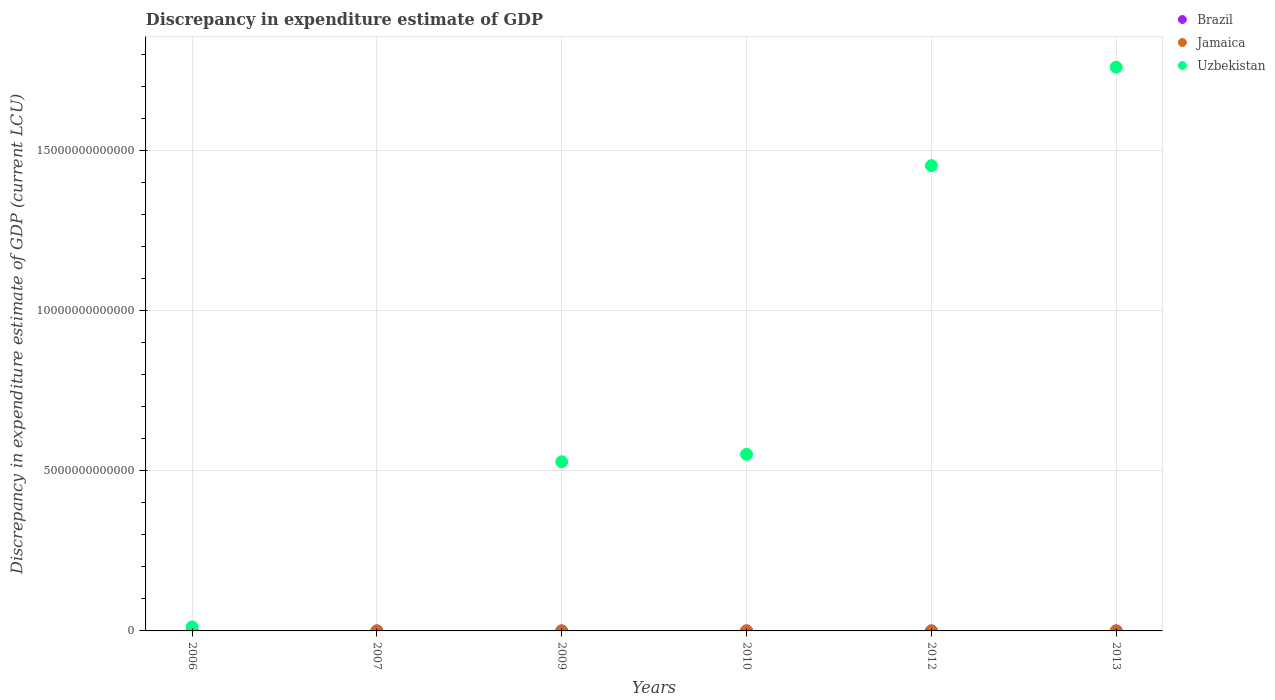Is the number of dotlines equal to the number of legend labels?
Provide a short and direct response. No. Across all years, what is the maximum discrepancy in expenditure estimate of GDP in Brazil?
Make the answer very short. 2.00e+06. In which year was the discrepancy in expenditure estimate of GDP in Uzbekistan maximum?
Make the answer very short. 2013. What is the total discrepancy in expenditure estimate of GDP in Jamaica in the graph?
Ensure brevity in your answer.  1.20e+06. What is the difference between the discrepancy in expenditure estimate of GDP in Jamaica in 2007 and that in 2012?
Provide a succinct answer. -8.00e+05. What is the difference between the discrepancy in expenditure estimate of GDP in Jamaica in 2006 and the discrepancy in expenditure estimate of GDP in Uzbekistan in 2010?
Provide a succinct answer. -5.51e+12. What is the average discrepancy in expenditure estimate of GDP in Brazil per year?
Provide a succinct answer. 6.67e+05. In the year 2010, what is the difference between the discrepancy in expenditure estimate of GDP in Brazil and discrepancy in expenditure estimate of GDP in Uzbekistan?
Offer a very short reply. -5.51e+12. What is the ratio of the discrepancy in expenditure estimate of GDP in Brazil in 2009 to that in 2010?
Your answer should be compact. 1. What is the difference between the highest and the second highest discrepancy in expenditure estimate of GDP in Brazil?
Offer a terse response. 1.00e+06. What is the difference between the highest and the lowest discrepancy in expenditure estimate of GDP in Jamaica?
Keep it short and to the point. 1.00e+06. In how many years, is the discrepancy in expenditure estimate of GDP in Jamaica greater than the average discrepancy in expenditure estimate of GDP in Jamaica taken over all years?
Your answer should be very brief. 1. Does the discrepancy in expenditure estimate of GDP in Jamaica monotonically increase over the years?
Make the answer very short. No. Is the discrepancy in expenditure estimate of GDP in Brazil strictly greater than the discrepancy in expenditure estimate of GDP in Uzbekistan over the years?
Your answer should be compact. No. Is the discrepancy in expenditure estimate of GDP in Uzbekistan strictly less than the discrepancy in expenditure estimate of GDP in Brazil over the years?
Ensure brevity in your answer.  No. How many dotlines are there?
Offer a terse response. 3. What is the difference between two consecutive major ticks on the Y-axis?
Ensure brevity in your answer.  5.00e+12. Does the graph contain any zero values?
Your response must be concise. Yes. Does the graph contain grids?
Your response must be concise. Yes. What is the title of the graph?
Keep it short and to the point. Discrepancy in expenditure estimate of GDP. What is the label or title of the X-axis?
Your answer should be very brief. Years. What is the label or title of the Y-axis?
Your answer should be very brief. Discrepancy in expenditure estimate of GDP (current LCU). What is the Discrepancy in expenditure estimate of GDP (current LCU) in Brazil in 2006?
Keep it short and to the point. 0. What is the Discrepancy in expenditure estimate of GDP (current LCU) of Jamaica in 2006?
Ensure brevity in your answer.  0. What is the Discrepancy in expenditure estimate of GDP (current LCU) of Uzbekistan in 2006?
Make the answer very short. 1.25e+11. What is the Discrepancy in expenditure estimate of GDP (current LCU) of Brazil in 2007?
Your answer should be compact. 0. What is the Discrepancy in expenditure estimate of GDP (current LCU) in Jamaica in 2007?
Your answer should be compact. 2.00e+05. What is the Discrepancy in expenditure estimate of GDP (current LCU) of Uzbekistan in 2007?
Ensure brevity in your answer.  0. What is the Discrepancy in expenditure estimate of GDP (current LCU) of Brazil in 2009?
Give a very brief answer. 1.00e+06. What is the Discrepancy in expenditure estimate of GDP (current LCU) of Jamaica in 2009?
Offer a very short reply. 0. What is the Discrepancy in expenditure estimate of GDP (current LCU) of Uzbekistan in 2009?
Your answer should be compact. 5.28e+12. What is the Discrepancy in expenditure estimate of GDP (current LCU) of Brazil in 2010?
Offer a terse response. 1.00e+06. What is the Discrepancy in expenditure estimate of GDP (current LCU) in Jamaica in 2010?
Make the answer very short. 0. What is the Discrepancy in expenditure estimate of GDP (current LCU) of Uzbekistan in 2010?
Keep it short and to the point. 5.51e+12. What is the Discrepancy in expenditure estimate of GDP (current LCU) of Jamaica in 2012?
Ensure brevity in your answer.  1.00e+06. What is the Discrepancy in expenditure estimate of GDP (current LCU) of Uzbekistan in 2012?
Make the answer very short. 1.45e+13. What is the Discrepancy in expenditure estimate of GDP (current LCU) in Brazil in 2013?
Your answer should be compact. 2.00e+06. What is the Discrepancy in expenditure estimate of GDP (current LCU) in Uzbekistan in 2013?
Provide a short and direct response. 1.76e+13. Across all years, what is the maximum Discrepancy in expenditure estimate of GDP (current LCU) of Brazil?
Make the answer very short. 2.00e+06. Across all years, what is the maximum Discrepancy in expenditure estimate of GDP (current LCU) in Jamaica?
Give a very brief answer. 1.00e+06. Across all years, what is the maximum Discrepancy in expenditure estimate of GDP (current LCU) in Uzbekistan?
Keep it short and to the point. 1.76e+13. What is the total Discrepancy in expenditure estimate of GDP (current LCU) in Brazil in the graph?
Your answer should be very brief. 4.00e+06. What is the total Discrepancy in expenditure estimate of GDP (current LCU) of Jamaica in the graph?
Ensure brevity in your answer.  1.20e+06. What is the total Discrepancy in expenditure estimate of GDP (current LCU) of Uzbekistan in the graph?
Your answer should be compact. 4.30e+13. What is the difference between the Discrepancy in expenditure estimate of GDP (current LCU) in Uzbekistan in 2006 and that in 2009?
Give a very brief answer. -5.15e+12. What is the difference between the Discrepancy in expenditure estimate of GDP (current LCU) of Uzbekistan in 2006 and that in 2010?
Give a very brief answer. -5.39e+12. What is the difference between the Discrepancy in expenditure estimate of GDP (current LCU) in Uzbekistan in 2006 and that in 2012?
Ensure brevity in your answer.  -1.44e+13. What is the difference between the Discrepancy in expenditure estimate of GDP (current LCU) of Uzbekistan in 2006 and that in 2013?
Ensure brevity in your answer.  -1.75e+13. What is the difference between the Discrepancy in expenditure estimate of GDP (current LCU) in Jamaica in 2007 and that in 2012?
Ensure brevity in your answer.  -8.00e+05. What is the difference between the Discrepancy in expenditure estimate of GDP (current LCU) in Brazil in 2009 and that in 2010?
Your answer should be compact. -0. What is the difference between the Discrepancy in expenditure estimate of GDP (current LCU) of Uzbekistan in 2009 and that in 2010?
Your response must be concise. -2.32e+11. What is the difference between the Discrepancy in expenditure estimate of GDP (current LCU) of Uzbekistan in 2009 and that in 2012?
Your response must be concise. -9.24e+12. What is the difference between the Discrepancy in expenditure estimate of GDP (current LCU) of Brazil in 2009 and that in 2013?
Offer a terse response. -1.00e+06. What is the difference between the Discrepancy in expenditure estimate of GDP (current LCU) in Uzbekistan in 2009 and that in 2013?
Your answer should be compact. -1.23e+13. What is the difference between the Discrepancy in expenditure estimate of GDP (current LCU) in Uzbekistan in 2010 and that in 2012?
Ensure brevity in your answer.  -9.01e+12. What is the difference between the Discrepancy in expenditure estimate of GDP (current LCU) of Uzbekistan in 2010 and that in 2013?
Ensure brevity in your answer.  -1.21e+13. What is the difference between the Discrepancy in expenditure estimate of GDP (current LCU) in Uzbekistan in 2012 and that in 2013?
Offer a terse response. -3.07e+12. What is the difference between the Discrepancy in expenditure estimate of GDP (current LCU) of Jamaica in 2007 and the Discrepancy in expenditure estimate of GDP (current LCU) of Uzbekistan in 2009?
Provide a short and direct response. -5.28e+12. What is the difference between the Discrepancy in expenditure estimate of GDP (current LCU) of Jamaica in 2007 and the Discrepancy in expenditure estimate of GDP (current LCU) of Uzbekistan in 2010?
Offer a terse response. -5.51e+12. What is the difference between the Discrepancy in expenditure estimate of GDP (current LCU) of Jamaica in 2007 and the Discrepancy in expenditure estimate of GDP (current LCU) of Uzbekistan in 2012?
Offer a terse response. -1.45e+13. What is the difference between the Discrepancy in expenditure estimate of GDP (current LCU) of Jamaica in 2007 and the Discrepancy in expenditure estimate of GDP (current LCU) of Uzbekistan in 2013?
Your response must be concise. -1.76e+13. What is the difference between the Discrepancy in expenditure estimate of GDP (current LCU) in Brazil in 2009 and the Discrepancy in expenditure estimate of GDP (current LCU) in Uzbekistan in 2010?
Give a very brief answer. -5.51e+12. What is the difference between the Discrepancy in expenditure estimate of GDP (current LCU) in Brazil in 2009 and the Discrepancy in expenditure estimate of GDP (current LCU) in Jamaica in 2012?
Offer a very short reply. -0. What is the difference between the Discrepancy in expenditure estimate of GDP (current LCU) of Brazil in 2009 and the Discrepancy in expenditure estimate of GDP (current LCU) of Uzbekistan in 2012?
Provide a short and direct response. -1.45e+13. What is the difference between the Discrepancy in expenditure estimate of GDP (current LCU) of Brazil in 2009 and the Discrepancy in expenditure estimate of GDP (current LCU) of Uzbekistan in 2013?
Provide a succinct answer. -1.76e+13. What is the difference between the Discrepancy in expenditure estimate of GDP (current LCU) of Brazil in 2010 and the Discrepancy in expenditure estimate of GDP (current LCU) of Uzbekistan in 2012?
Keep it short and to the point. -1.45e+13. What is the difference between the Discrepancy in expenditure estimate of GDP (current LCU) of Brazil in 2010 and the Discrepancy in expenditure estimate of GDP (current LCU) of Uzbekistan in 2013?
Provide a short and direct response. -1.76e+13. What is the difference between the Discrepancy in expenditure estimate of GDP (current LCU) in Jamaica in 2012 and the Discrepancy in expenditure estimate of GDP (current LCU) in Uzbekistan in 2013?
Your response must be concise. -1.76e+13. What is the average Discrepancy in expenditure estimate of GDP (current LCU) of Brazil per year?
Keep it short and to the point. 6.67e+05. What is the average Discrepancy in expenditure estimate of GDP (current LCU) of Uzbekistan per year?
Provide a succinct answer. 7.17e+12. In the year 2009, what is the difference between the Discrepancy in expenditure estimate of GDP (current LCU) of Brazil and Discrepancy in expenditure estimate of GDP (current LCU) of Uzbekistan?
Offer a very short reply. -5.28e+12. In the year 2010, what is the difference between the Discrepancy in expenditure estimate of GDP (current LCU) in Brazil and Discrepancy in expenditure estimate of GDP (current LCU) in Uzbekistan?
Your response must be concise. -5.51e+12. In the year 2012, what is the difference between the Discrepancy in expenditure estimate of GDP (current LCU) in Jamaica and Discrepancy in expenditure estimate of GDP (current LCU) in Uzbekistan?
Your answer should be compact. -1.45e+13. In the year 2013, what is the difference between the Discrepancy in expenditure estimate of GDP (current LCU) of Brazil and Discrepancy in expenditure estimate of GDP (current LCU) of Uzbekistan?
Your answer should be compact. -1.76e+13. What is the ratio of the Discrepancy in expenditure estimate of GDP (current LCU) in Uzbekistan in 2006 to that in 2009?
Make the answer very short. 0.02. What is the ratio of the Discrepancy in expenditure estimate of GDP (current LCU) of Uzbekistan in 2006 to that in 2010?
Provide a short and direct response. 0.02. What is the ratio of the Discrepancy in expenditure estimate of GDP (current LCU) of Uzbekistan in 2006 to that in 2012?
Your response must be concise. 0.01. What is the ratio of the Discrepancy in expenditure estimate of GDP (current LCU) in Uzbekistan in 2006 to that in 2013?
Give a very brief answer. 0.01. What is the ratio of the Discrepancy in expenditure estimate of GDP (current LCU) of Brazil in 2009 to that in 2010?
Keep it short and to the point. 1. What is the ratio of the Discrepancy in expenditure estimate of GDP (current LCU) of Uzbekistan in 2009 to that in 2010?
Give a very brief answer. 0.96. What is the ratio of the Discrepancy in expenditure estimate of GDP (current LCU) in Uzbekistan in 2009 to that in 2012?
Provide a short and direct response. 0.36. What is the ratio of the Discrepancy in expenditure estimate of GDP (current LCU) of Brazil in 2009 to that in 2013?
Offer a very short reply. 0.5. What is the ratio of the Discrepancy in expenditure estimate of GDP (current LCU) of Uzbekistan in 2009 to that in 2013?
Keep it short and to the point. 0.3. What is the ratio of the Discrepancy in expenditure estimate of GDP (current LCU) of Uzbekistan in 2010 to that in 2012?
Your answer should be compact. 0.38. What is the ratio of the Discrepancy in expenditure estimate of GDP (current LCU) in Uzbekistan in 2010 to that in 2013?
Give a very brief answer. 0.31. What is the ratio of the Discrepancy in expenditure estimate of GDP (current LCU) in Uzbekistan in 2012 to that in 2013?
Offer a terse response. 0.83. What is the difference between the highest and the second highest Discrepancy in expenditure estimate of GDP (current LCU) in Brazil?
Make the answer very short. 1.00e+06. What is the difference between the highest and the second highest Discrepancy in expenditure estimate of GDP (current LCU) in Uzbekistan?
Make the answer very short. 3.07e+12. What is the difference between the highest and the lowest Discrepancy in expenditure estimate of GDP (current LCU) in Brazil?
Your answer should be very brief. 2.00e+06. What is the difference between the highest and the lowest Discrepancy in expenditure estimate of GDP (current LCU) of Jamaica?
Keep it short and to the point. 1.00e+06. What is the difference between the highest and the lowest Discrepancy in expenditure estimate of GDP (current LCU) in Uzbekistan?
Keep it short and to the point. 1.76e+13. 